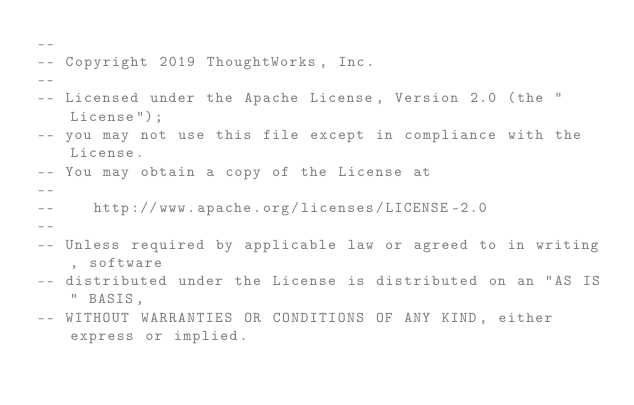<code> <loc_0><loc_0><loc_500><loc_500><_SQL_>--
-- Copyright 2019 ThoughtWorks, Inc.
--
-- Licensed under the Apache License, Version 2.0 (the "License");
-- you may not use this file except in compliance with the License.
-- You may obtain a copy of the License at
--
--    http://www.apache.org/licenses/LICENSE-2.0
--
-- Unless required by applicable law or agreed to in writing, software
-- distributed under the License is distributed on an "AS IS" BASIS,
-- WITHOUT WARRANTIES OR CONDITIONS OF ANY KIND, either express or implied.</code> 